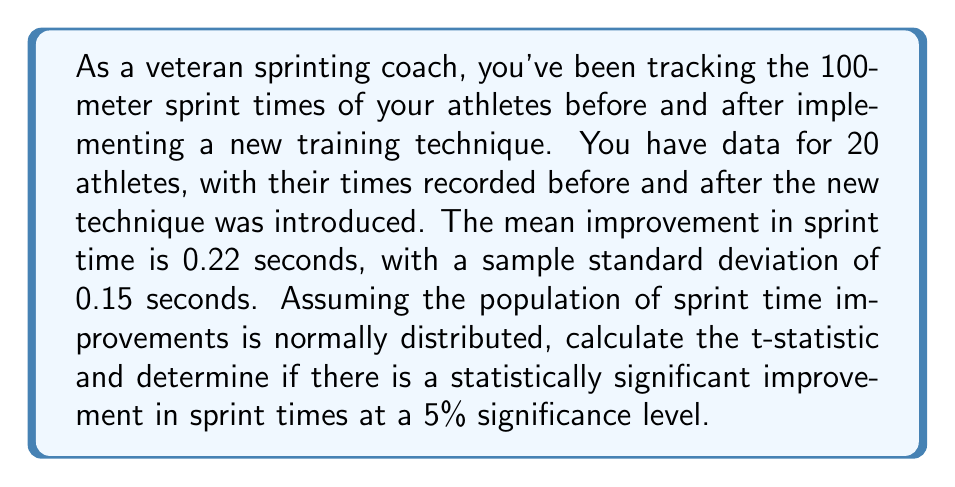Show me your answer to this math problem. To determine if there is a statistically significant improvement in sprint times, we need to perform a one-sample t-test. We'll follow these steps:

1. Calculate the t-statistic
2. Determine the critical t-value
3. Compare the t-statistic to the critical t-value

Step 1: Calculate the t-statistic

The formula for the t-statistic is:

$$ t = \frac{\bar{x} - \mu_0}{s / \sqrt{n}} $$

Where:
$\bar{x}$ = sample mean (0.22 seconds)
$\mu_0$ = hypothesized population mean (0, as we're testing if there's any improvement)
$s$ = sample standard deviation (0.15 seconds)
$n$ = sample size (20)

Plugging in the values:

$$ t = \frac{0.22 - 0}{0.15 / \sqrt{20}} = \frac{0.22}{0.15 / 4.472} = \frac{0.22}{0.0335} = 6.567 $$

Step 2: Determine the critical t-value

For a 5% significance level (α = 0.05) and 19 degrees of freedom (n - 1 = 19), the critical t-value for a two-tailed test is approximately 2.093.

Step 3: Compare the t-statistic to the critical t-value

Our calculated t-statistic (6.567) is greater than the critical t-value (2.093).

Therefore, we reject the null hypothesis that there is no improvement in sprint times. This suggests that there is a statistically significant improvement in sprint times after implementing the new training technique.
Answer: The t-statistic is 6.567, which is greater than the critical t-value of 2.093 at a 5% significance level. Therefore, there is a statistically significant improvement in sprint times after implementing the new training technique. 